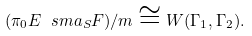Convert formula to latex. <formula><loc_0><loc_0><loc_500><loc_500>( \pi _ { 0 } E \ s m a _ { S } F ) / m \cong W ( \Gamma _ { 1 } , \Gamma _ { 2 } ) .</formula> 